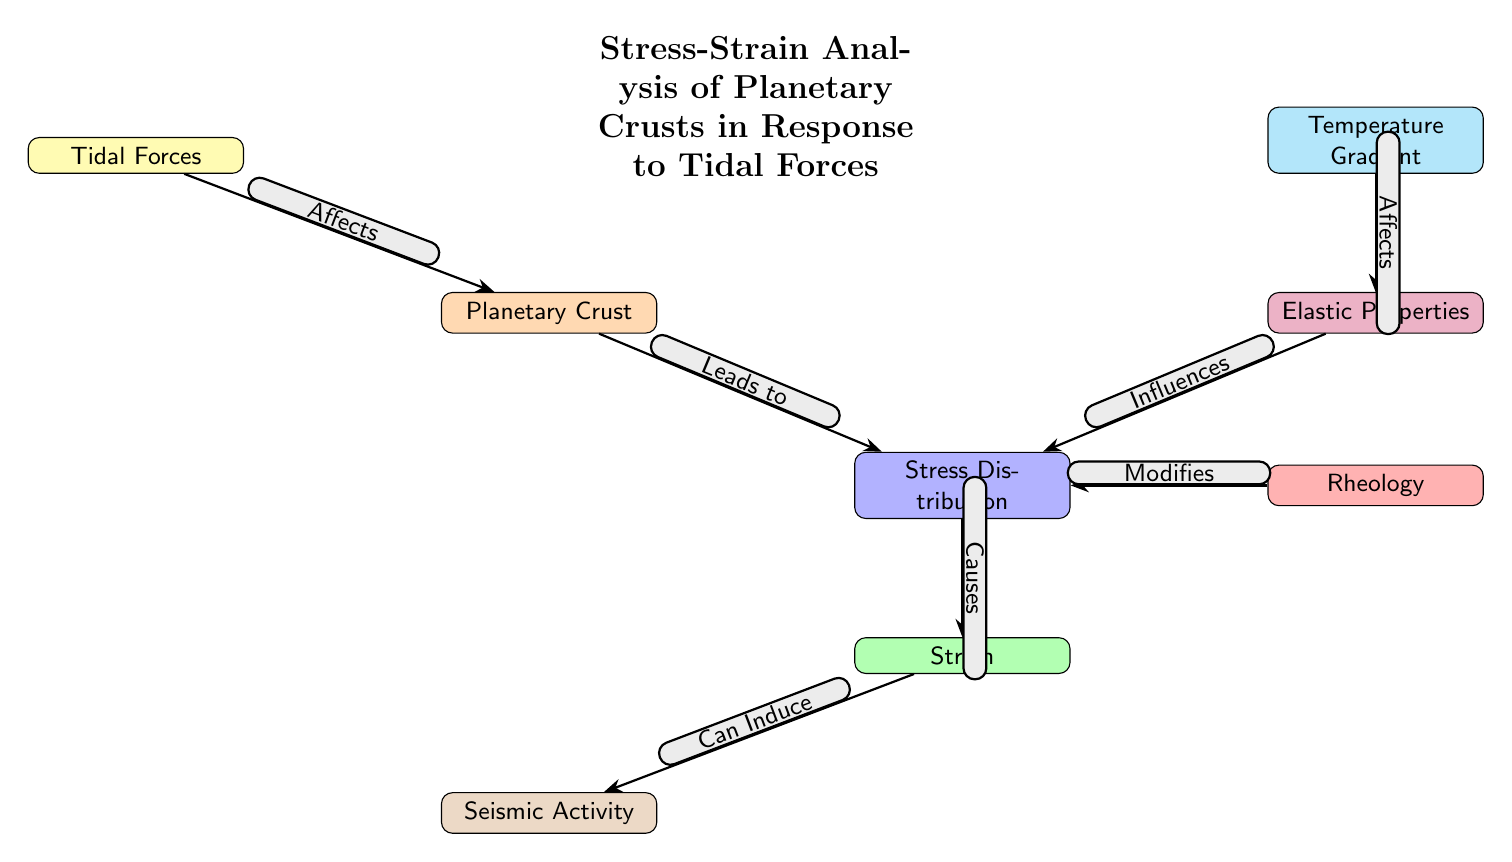What is the main subject of the diagram? The title at the top of the diagram clearly states that it concerns the "Stress-Strain Analysis of Planetary Crusts in Response to Tidal Forces". Therefore, the main subject revolves around analyzing the stress and strain experienced by planetary crusts due to tidal forces.
Answer: Stress-Strain Analysis of Planetary Crusts in Response to Tidal Forces How many nodes are present in the diagram? By counting the individual labeled boxes in the diagram, there are a total of eight distinct nodes connected by arrows.
Answer: Eight What is the relationship between Tidal Forces and the Planetary Crust? The arrow indicates that Tidal Forces "Affects" the Planetary Crust, illustrating a direct relationship where the tidal forces influence the crust.
Answer: Affects Which node is influenced by Elastic Properties? The diagram indicates that Elastic Properties "Influences" the Stress Distribution node, meaning that elastic characteristics of materials affect how stress is distributed in the crust.
Answer: Stress Distribution What does Strain in the diagram result from? The diagram connects Stress Distribution to Strain with an arrow labeled "Causes", meaning that changes in stress will result in strain within the material.
Answer: Causes What does Seismic Activity depend on? The diagram shows that Seismic Activity is connected to Strain with an arrow labeled "Can Induce", which indicates that changes in strain can lead to seismic activity in the crust.
Answer: Can Induce Which factor modifies the Stress Distribution? According to the diagram, Rheology has a direct influence on the Stress Distribution, as indicated by the labeled arrow "Modifies".
Answer: Modifies How does Temperature Gradient relate to Elastic Properties? The diagram shows the Temperature Gradient affects Elastic Properties, indicating that variations in temperature can impact the elastic behavior of materials in the planetary crust.
Answer: Affects 